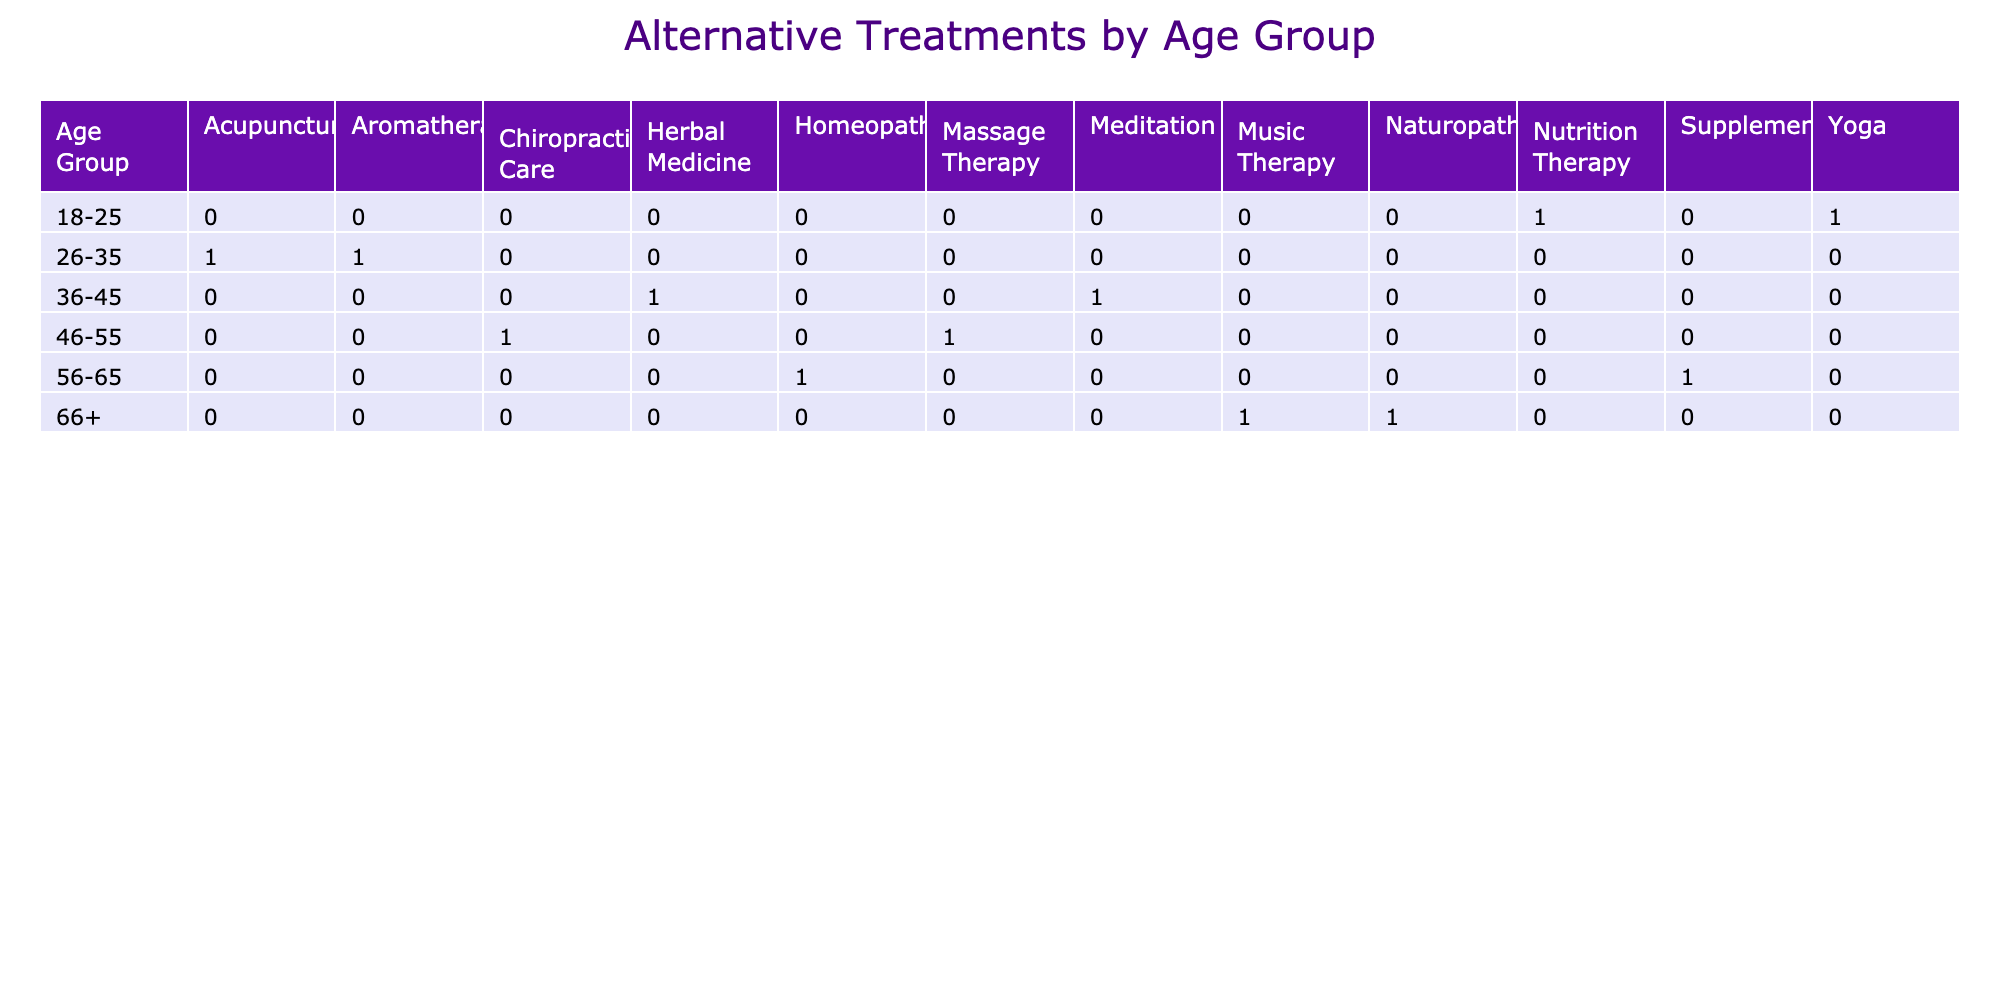What is the preferred alternative treatment for the 36-45 age group? The table shows that for the 36-45 age group, the preferred alternative treatments are Herbal Medicine for males and Meditation for females.
Answer: Herbal Medicine and Meditation Which age group has the highest count for Acupuncture as a preferred alternative treatment? By examining the table, Acupuncture appears only in the 26-35 age group, where it is preferred by females. Therefore, this is the only age group associated with Acupuncture.
Answer: 26-35 True or False: Naturopathy is the preferred alternative treatment for any age group. Looking through the table, Naturopathy is listed as the preferred alternative treatment for the 66+ age group. This confirms that it is indeed preferred by some individuals in that age range.
Answer: True How many alternative treatments are preferred by males aged 46-55? For males aged 46-55, the preferred alternative treatment listed is Chiropractic Care, which is the only one available in this age category. Thus, there is just one treatment for this age group.
Answer: 1 What is the total number of alternative treatments preferred by females across all age groups? Summarizing the table for females, the preferred alternative treatments are Nutrition Therapy, Acupuncture, Meditation, Massage Therapy, Homeopathy, and Music Therapy. This gives a total of 6 different treatments preferred by females.
Answer: 6 In which age group is the least number of alternative treatments preferred? Analyzing the table, Acupuncture is the only treatment listed for the 26-35 age group, while other age groups have a minimum of two treatments suggested. Therefore, the 26-35 age group has the least number of alternative treatments preferred.
Answer: 26-35 What is the difference in the number of preferred treatments between the age groups 18-25 and 56-65? In the age group of 18-25, there are 2 preferred treatments (Yoga, Nutrition Therapy), while in the 56-65 age group, there are also 2 treatments (Supplementation, Homeopathy). Thus, the difference is 2 - 2 = 0.
Answer: 0 Which gender has a preferred alternative treatment for Osteoporosis? The table indicates that Osteoporosis is a chronic condition for females in the 56-65 age group, where Homeopathy is the preferred treatment. Therefore, it's the females who have a preferred treatment for this condition.
Answer: Female 